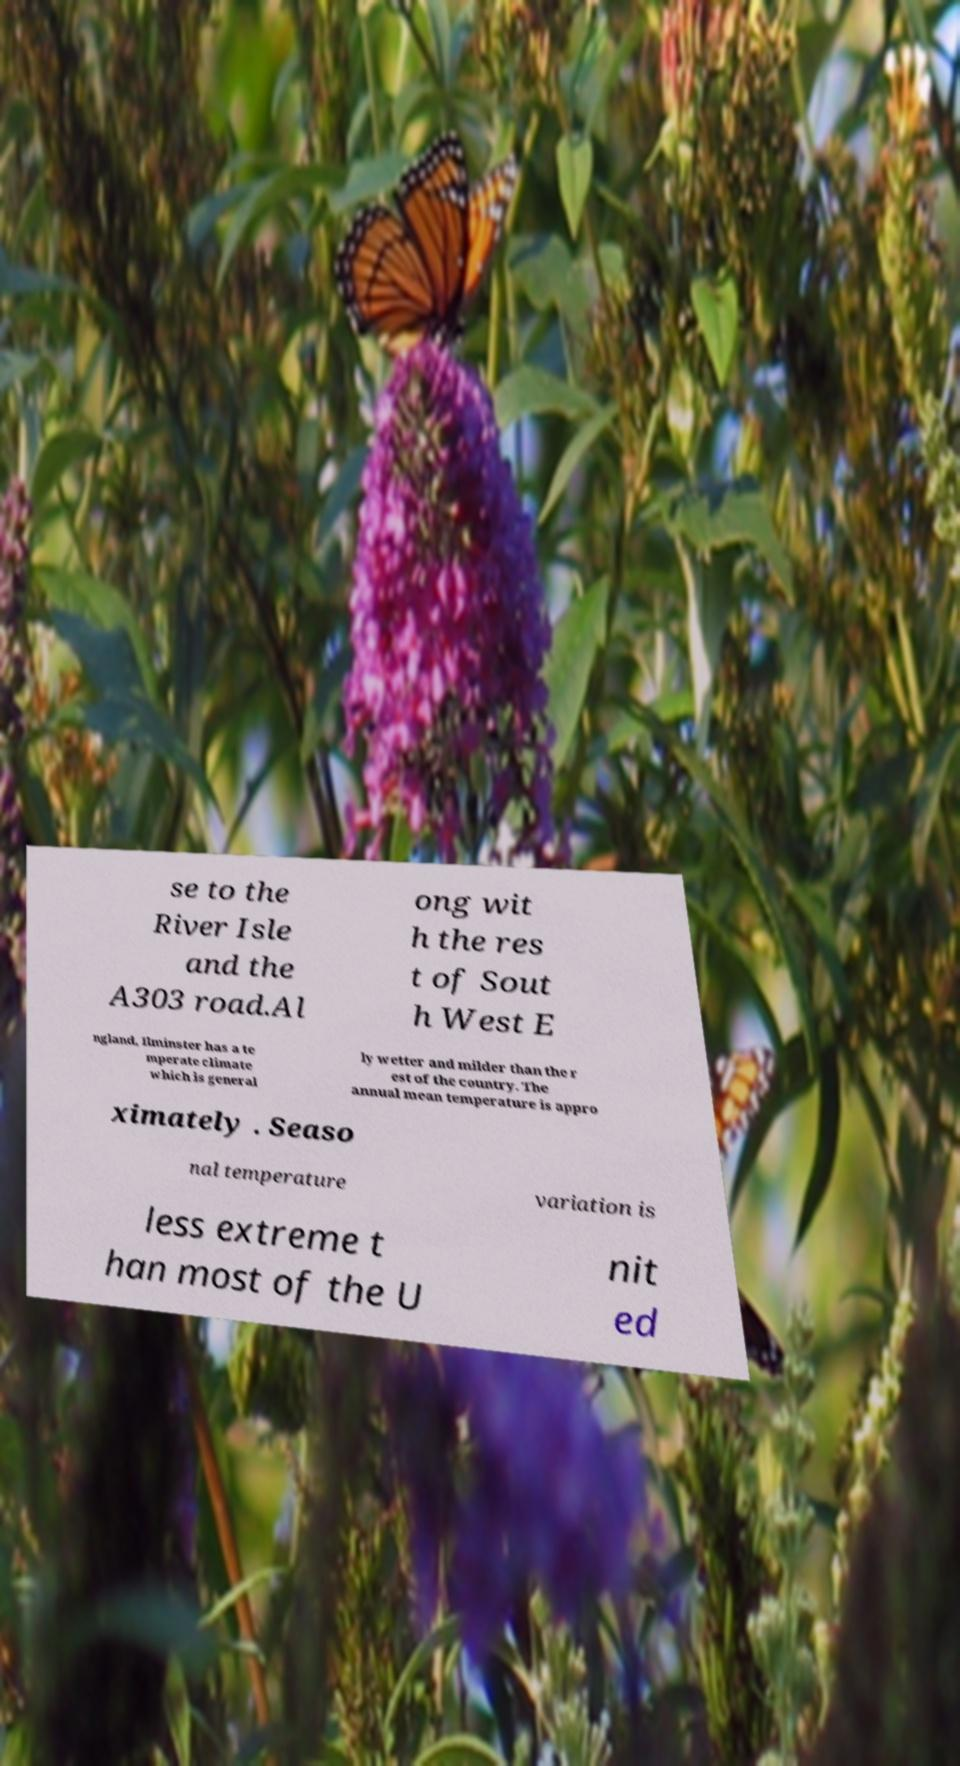Can you accurately transcribe the text from the provided image for me? se to the River Isle and the A303 road.Al ong wit h the res t of Sout h West E ngland, Ilminster has a te mperate climate which is general ly wetter and milder than the r est of the country. The annual mean temperature is appro ximately . Seaso nal temperature variation is less extreme t han most of the U nit ed 